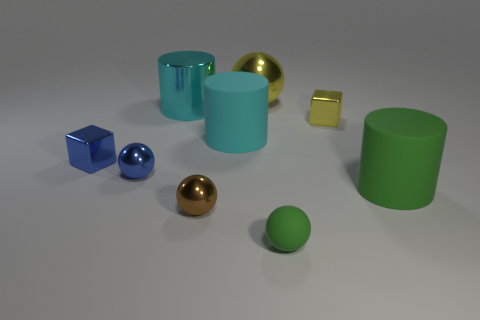Is there a small blue cube that has the same material as the tiny yellow block?
Offer a very short reply. Yes. What is the material of the blue ball that is the same size as the green ball?
Keep it short and to the point. Metal. What is the ball that is behind the big cyan cylinder left of the tiny brown sphere made of?
Your answer should be compact. Metal. Is the shape of the matte thing that is in front of the big green thing the same as  the tiny brown object?
Ensure brevity in your answer.  Yes. What is the color of the other large object that is the same material as the large yellow object?
Provide a short and direct response. Cyan. What is the green thing that is on the right side of the small yellow metal block made of?
Give a very brief answer. Rubber. Do the cyan matte object and the large shiny thing that is in front of the big metallic ball have the same shape?
Ensure brevity in your answer.  Yes. What material is the object that is both in front of the small yellow object and right of the tiny green matte object?
Offer a very short reply. Rubber. There is a metallic cylinder that is the same size as the cyan rubber cylinder; what color is it?
Ensure brevity in your answer.  Cyan. Is the material of the small blue ball the same as the small ball that is in front of the brown metal thing?
Give a very brief answer. No. 